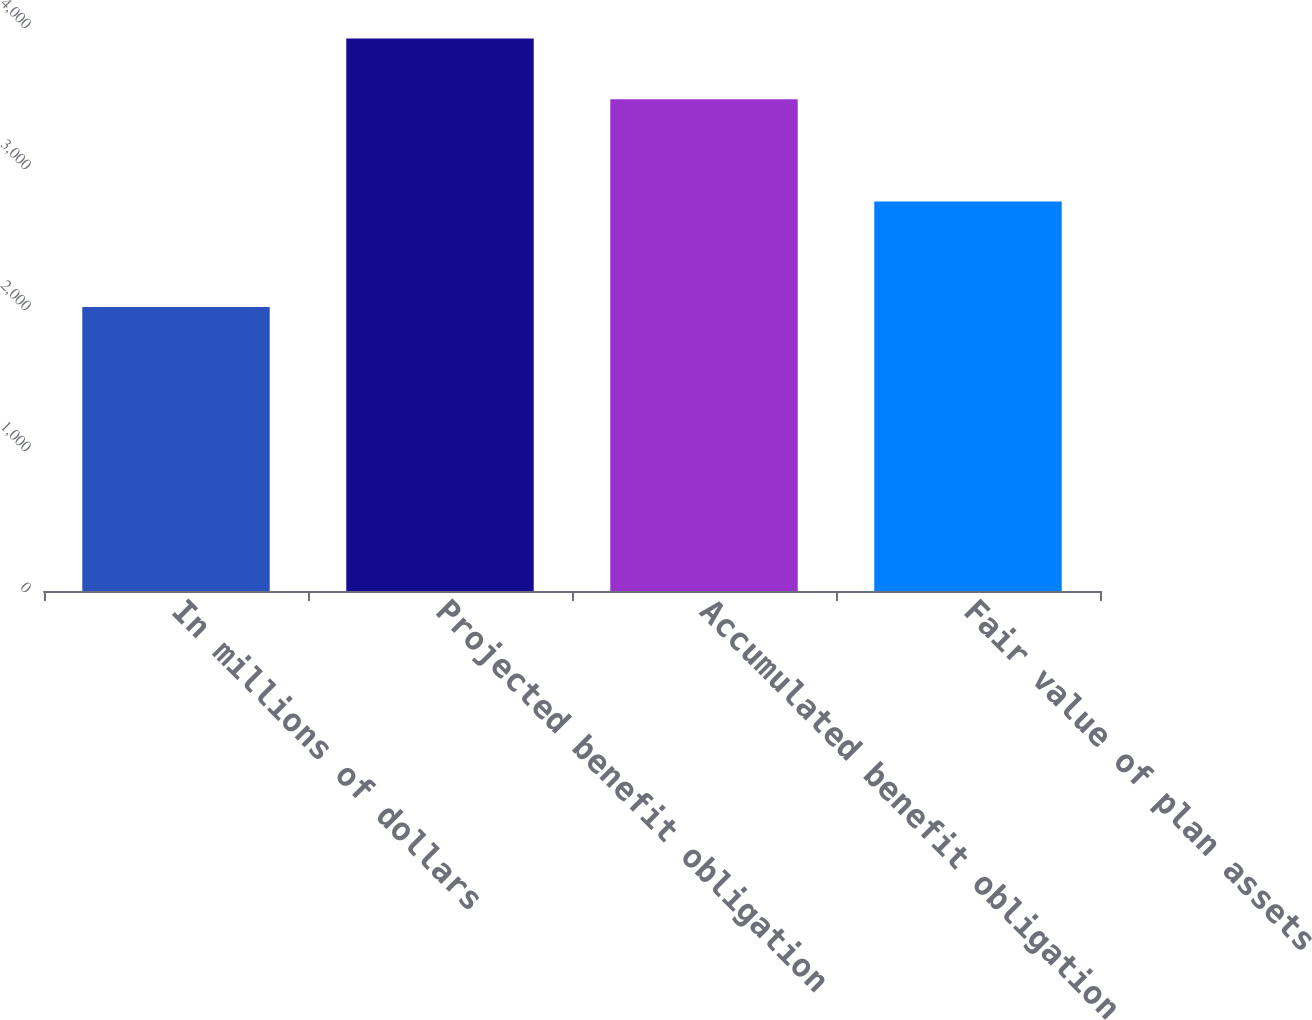Convert chart to OTSL. <chart><loc_0><loc_0><loc_500><loc_500><bar_chart><fcel>In millions of dollars<fcel>Projected benefit obligation<fcel>Accumulated benefit obligation<fcel>Fair value of plan assets<nl><fcel>2015<fcel>3918<fcel>3488<fcel>2762<nl></chart> 